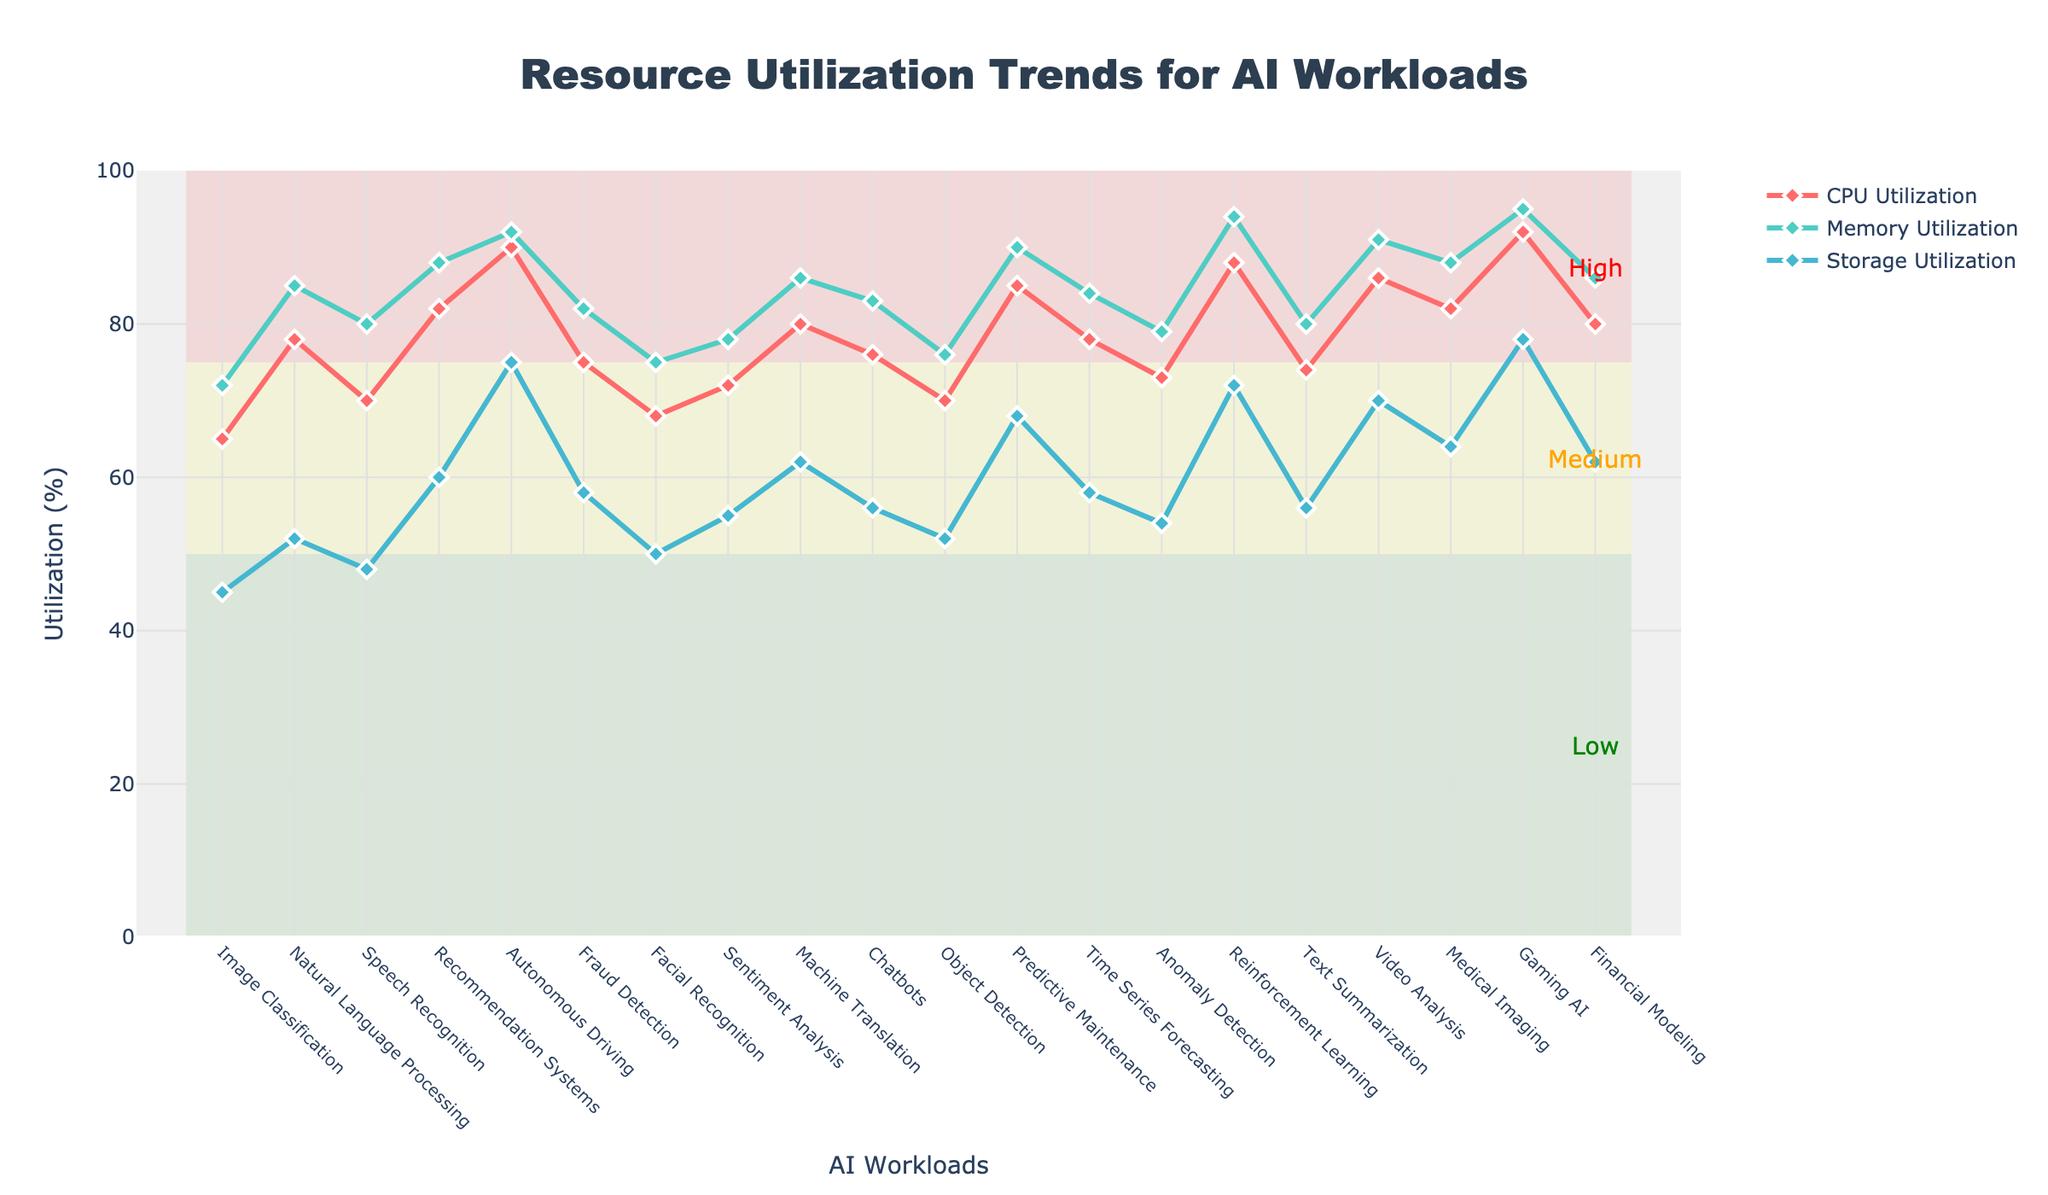Which AI workload has the highest CPU utilization? Review the graph and identify which AI workload has the highest line peak for CPU utilization.
Answer: Gaming AI Which AI workload has the lowest Memory utilization? Look for the lowest point on the Memory Utilization line on the graph and check the corresponding AI workload.
Answer: Image Classification Compare the CPU utilization of Recommendation Systems and Video Analysis. Which one is higher? Find the data points for CPU utilization for both Recommendation Systems and Video Analysis, then compare the values.
Answer: Video Analysis What's the average Storage utilization across Natural Language Processing, Sentiment Analysis, and Object Detection? Add the storage utilization values for these three workloads (52 + 55 + 52) and divide by 3.
Answer: 53 Which three AI workloads have the highest Memory utilization? Identify the top three peak values on the Memory Utilization line, noting the corresponding AI workloads.
Answer: Gaming AI, Autonomous Driving, Reinforcement Learning What’s the difference between the highest and lowest CPU utilization values? Find the maximum and minimum values in the CPU Utilization line, then subtract the minimum from the maximum.
Answer: 27 Is the Memory utilization for Chatbots higher than its Storage utilization? Compare the data points for Memory and Storage Utilization for Chatbots.
Answer: Yes Which AI workload shows equal values for both Memory and Storage utilization? Identify an AI workload where the Memory and Storage Utilization lines intersect at the same value.
Answer: None What's the sum of CPU and Storage utilization for Financial Modeling? Add the CPU utilization value and the Storage utilization value for Financial Modeling (80 + 62).
Answer: 142 Is there any AI workload where the CPU Utilization is within the "Low" utilization range (0-50%)? Determine if any points on the CPU Utilization line fall within the shaded green rectangle for "Low" utilization.
Answer: No 